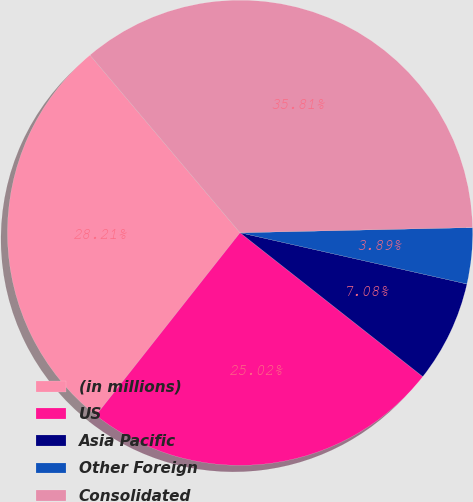<chart> <loc_0><loc_0><loc_500><loc_500><pie_chart><fcel>(in millions)<fcel>US<fcel>Asia Pacific<fcel>Other Foreign<fcel>Consolidated<nl><fcel>28.21%<fcel>25.02%<fcel>7.08%<fcel>3.89%<fcel>35.81%<nl></chart> 